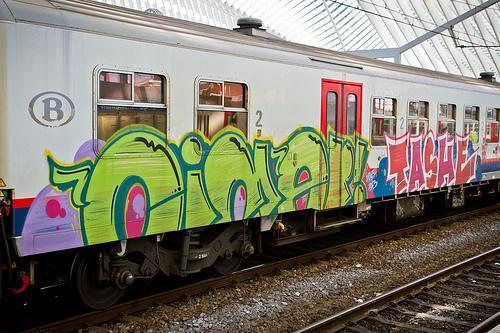How many tracks are there?
Give a very brief answer. 2. 